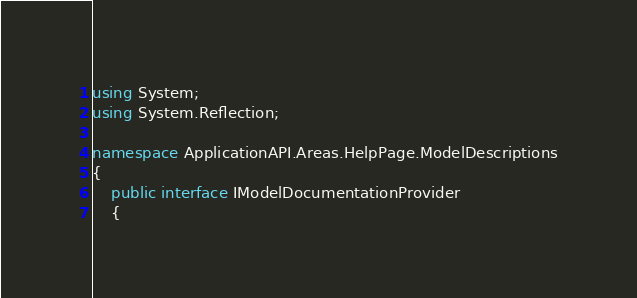Convert code to text. <code><loc_0><loc_0><loc_500><loc_500><_C#_>using System;
using System.Reflection;

namespace ApplicationAPI.Areas.HelpPage.ModelDescriptions
{
    public interface IModelDocumentationProvider
    {</code> 